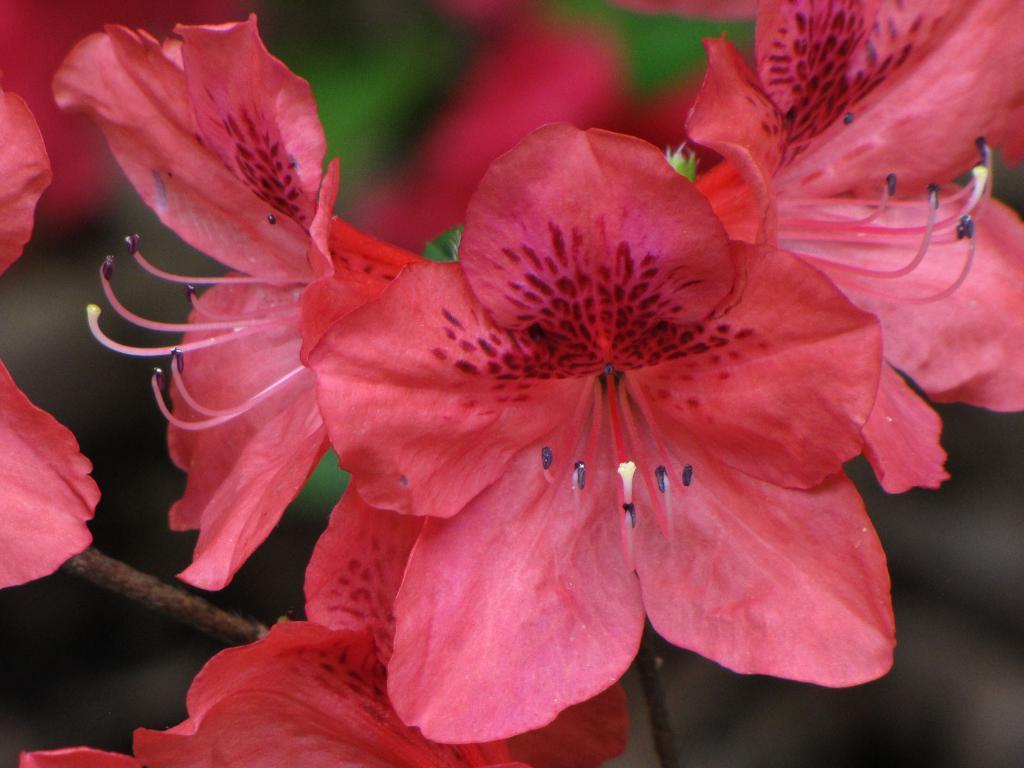Could you give a brief overview of what you see in this image? In this image I can see few red color flowers to the stems. The background is blurred. 